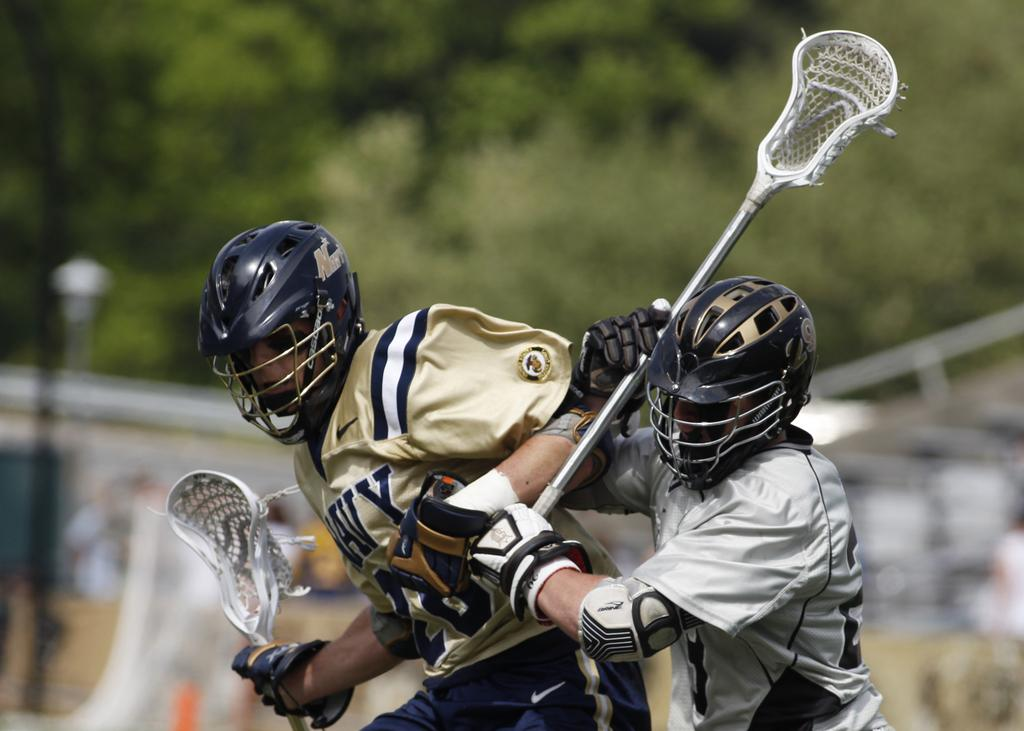How many people are present in the image? There are two people in the image. What are the people holding in their hands? The people are holding bats in the image. What can be seen in the background of the image? There are trees in the background of the image. What type of patch can be seen on the people's clothing in the image? There is no patch visible on the people's clothing in the image. What kind of plants are growing near the trees in the background? The image does not provide information about plants growing near the trees in the background. 